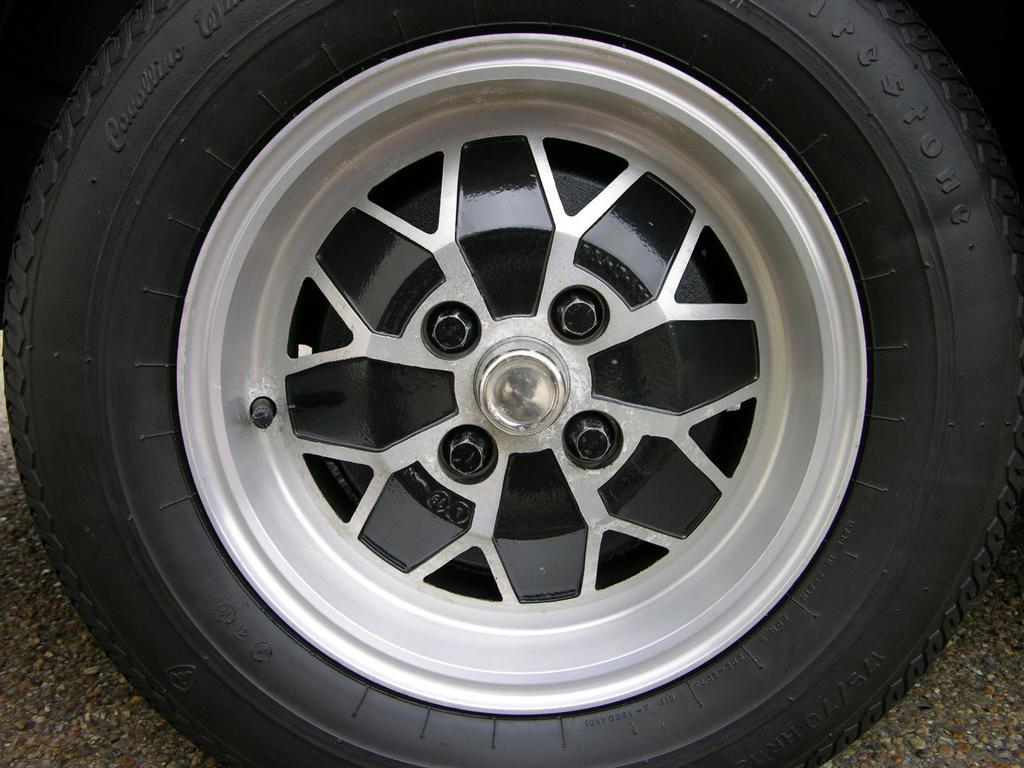What is the main object in the picture? There is a wheel in the picture. What are the threads on the wheel used for? The threads on the wheel are used for a specific purpose, but we cannot determine that from the image alone. What is the name of the wheel? The wheel has a name, but we cannot determine it from the image alone. What are the bolts associated with the wheel used for? The bolts associated with the wheel are used for a specific purpose, but we cannot determine that from the image alone. What is the rim on the wheel used for? The rim on the wheel is used for a specific purpose, but we cannot determine that from the image alone. What type of canvas is being used to create the wheel in the image? There is no canvas present in the image; it features a wheel with threads, bolts, and a rim. 